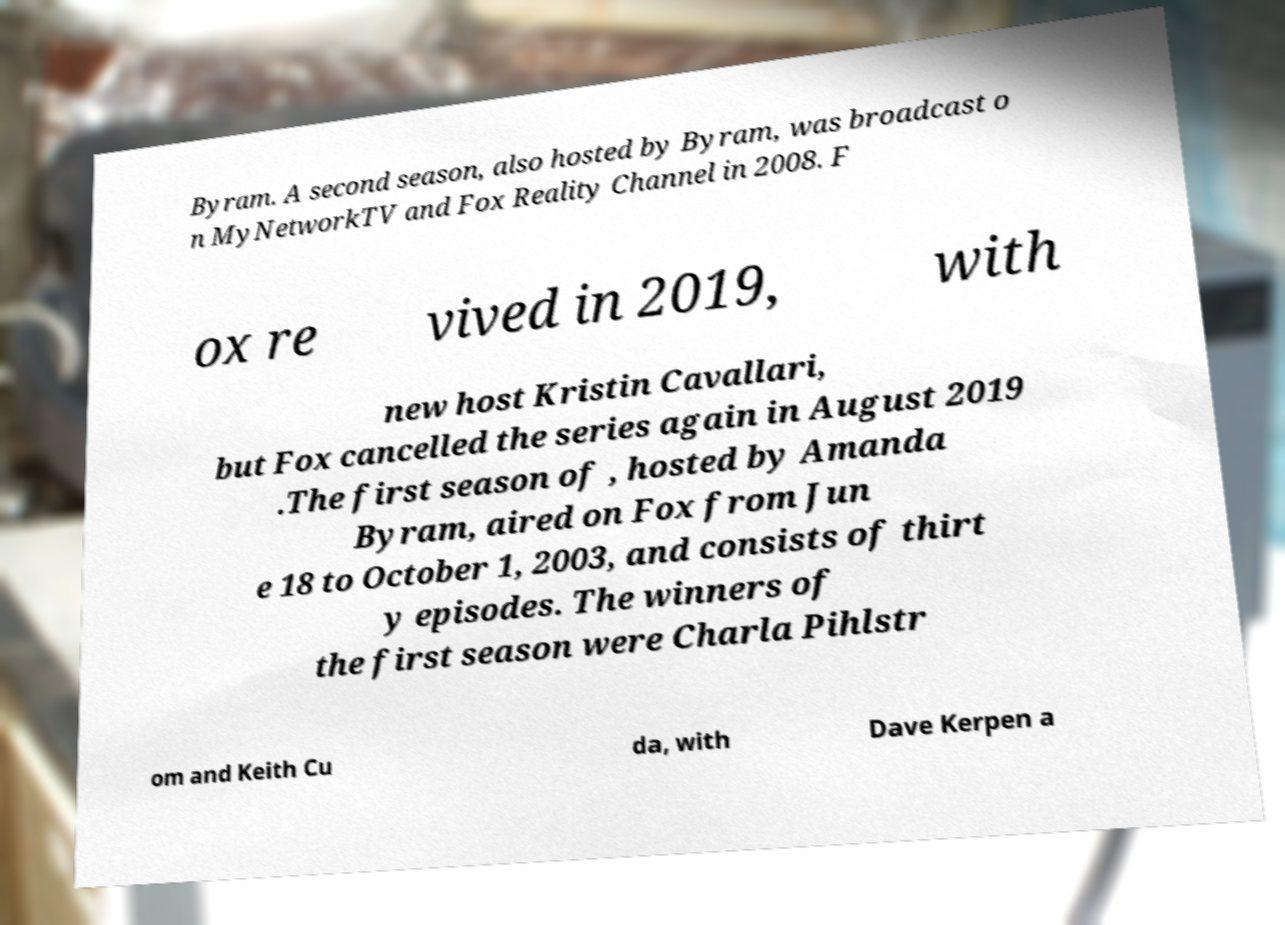Can you accurately transcribe the text from the provided image for me? Byram. A second season, also hosted by Byram, was broadcast o n MyNetworkTV and Fox Reality Channel in 2008. F ox re vived in 2019, with new host Kristin Cavallari, but Fox cancelled the series again in August 2019 .The first season of , hosted by Amanda Byram, aired on Fox from Jun e 18 to October 1, 2003, and consists of thirt y episodes. The winners of the first season were Charla Pihlstr om and Keith Cu da, with Dave Kerpen a 